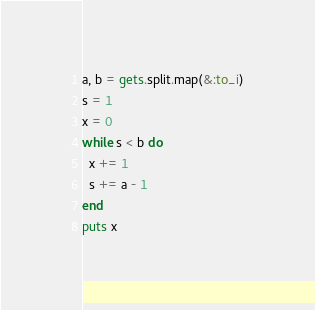Convert code to text. <code><loc_0><loc_0><loc_500><loc_500><_Ruby_>a, b = gets.split.map(&:to_i)
s = 1
x = 0
while s < b do
  x += 1
  s += a - 1
end
puts x
</code> 